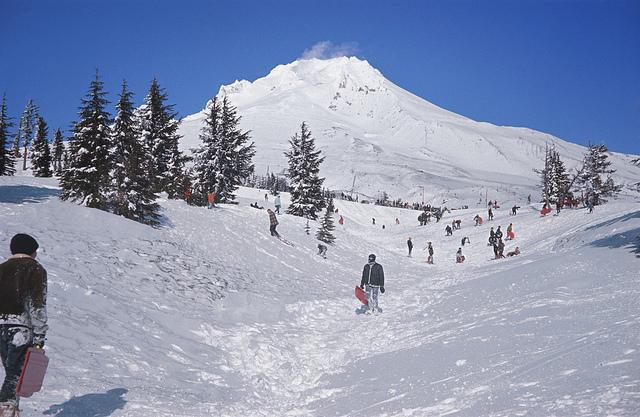How many people are skiing?
Give a very brief answer. 0. How many people are in the picture?
Give a very brief answer. 2. 